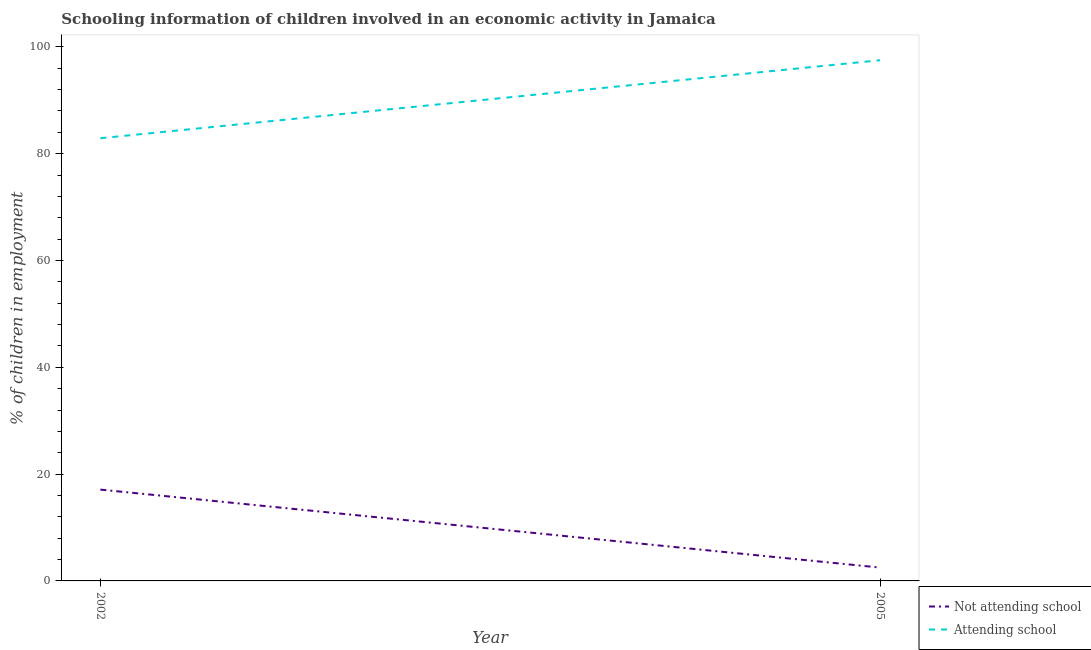What is the percentage of employed children who are attending school in 2002?
Ensure brevity in your answer.  82.9. Across all years, what is the maximum percentage of employed children who are attending school?
Provide a succinct answer. 97.5. Across all years, what is the minimum percentage of employed children who are attending school?
Ensure brevity in your answer.  82.9. What is the total percentage of employed children who are not attending school in the graph?
Offer a very short reply. 19.6. What is the difference between the percentage of employed children who are attending school in 2002 and that in 2005?
Offer a terse response. -14.6. What is the difference between the percentage of employed children who are attending school in 2005 and the percentage of employed children who are not attending school in 2002?
Provide a short and direct response. 80.4. What is the average percentage of employed children who are not attending school per year?
Your answer should be compact. 9.8. In the year 2002, what is the difference between the percentage of employed children who are not attending school and percentage of employed children who are attending school?
Offer a very short reply. -65.8. What is the ratio of the percentage of employed children who are attending school in 2002 to that in 2005?
Keep it short and to the point. 0.85. Is the percentage of employed children who are not attending school in 2002 less than that in 2005?
Give a very brief answer. No. Is the percentage of employed children who are attending school strictly less than the percentage of employed children who are not attending school over the years?
Give a very brief answer. No. What is the difference between two consecutive major ticks on the Y-axis?
Provide a succinct answer. 20. Does the graph contain grids?
Offer a very short reply. No. Where does the legend appear in the graph?
Give a very brief answer. Bottom right. How many legend labels are there?
Keep it short and to the point. 2. What is the title of the graph?
Ensure brevity in your answer.  Schooling information of children involved in an economic activity in Jamaica. Does "State government" appear as one of the legend labels in the graph?
Offer a very short reply. No. What is the label or title of the Y-axis?
Provide a short and direct response. % of children in employment. What is the % of children in employment in Attending school in 2002?
Make the answer very short. 82.9. What is the % of children in employment in Not attending school in 2005?
Keep it short and to the point. 2.5. What is the % of children in employment of Attending school in 2005?
Offer a very short reply. 97.5. Across all years, what is the maximum % of children in employment in Attending school?
Keep it short and to the point. 97.5. Across all years, what is the minimum % of children in employment of Attending school?
Provide a succinct answer. 82.9. What is the total % of children in employment in Not attending school in the graph?
Offer a terse response. 19.6. What is the total % of children in employment in Attending school in the graph?
Give a very brief answer. 180.4. What is the difference between the % of children in employment of Not attending school in 2002 and that in 2005?
Offer a terse response. 14.6. What is the difference between the % of children in employment in Attending school in 2002 and that in 2005?
Your answer should be very brief. -14.6. What is the difference between the % of children in employment of Not attending school in 2002 and the % of children in employment of Attending school in 2005?
Offer a terse response. -80.4. What is the average % of children in employment of Attending school per year?
Provide a succinct answer. 90.2. In the year 2002, what is the difference between the % of children in employment of Not attending school and % of children in employment of Attending school?
Make the answer very short. -65.8. In the year 2005, what is the difference between the % of children in employment of Not attending school and % of children in employment of Attending school?
Provide a short and direct response. -95. What is the ratio of the % of children in employment in Not attending school in 2002 to that in 2005?
Your answer should be compact. 6.84. What is the ratio of the % of children in employment in Attending school in 2002 to that in 2005?
Keep it short and to the point. 0.85. What is the difference between the highest and the second highest % of children in employment of Not attending school?
Ensure brevity in your answer.  14.6. What is the difference between the highest and the second highest % of children in employment in Attending school?
Provide a succinct answer. 14.6. What is the difference between the highest and the lowest % of children in employment in Not attending school?
Provide a succinct answer. 14.6. 